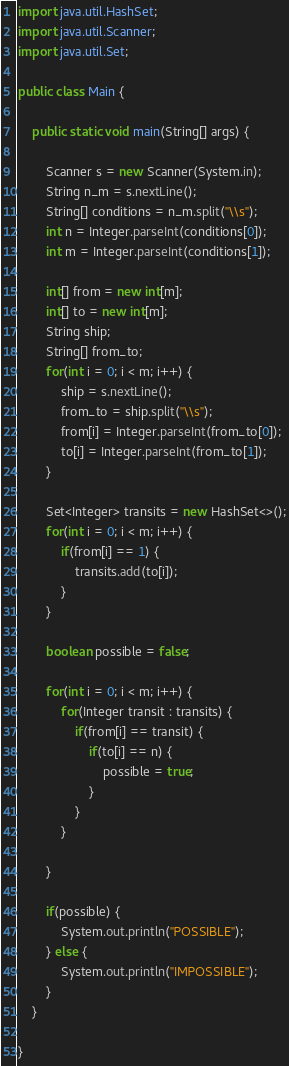Convert code to text. <code><loc_0><loc_0><loc_500><loc_500><_Java_>import java.util.HashSet;
import java.util.Scanner;
import java.util.Set;

public class Main {

	public static void main(String[] args) {
		
		Scanner s = new Scanner(System.in);
		String n_m = s.nextLine();
		String[] conditions = n_m.split("\\s");
		int n = Integer.parseInt(conditions[0]);
		int m = Integer.parseInt(conditions[1]);
		
		int[] from = new int[m];
		int[] to = new int[m];
		String ship;
		String[] from_to;
		for(int i = 0; i < m; i++) {
			ship = s.nextLine();
			from_to = ship.split("\\s");
			from[i] = Integer.parseInt(from_to[0]);
			to[i] = Integer.parseInt(from_to[1]);
		}
		
		Set<Integer> transits = new HashSet<>();
		for(int i = 0; i < m; i++) {
			if(from[i] == 1) {
				transits.add(to[i]);
			}
		}
		
		boolean possible = false;
		
		for(int i = 0; i < m; i++) {
			for(Integer transit : transits) {
				if(from[i] == transit) {
					if(to[i] == n) {
						possible = true;
					}
				}
			}
			
		}
		
		if(possible) {
			System.out.println("POSSIBLE");
		} else {
			System.out.println("IMPOSSIBLE");
		}
	}

}</code> 